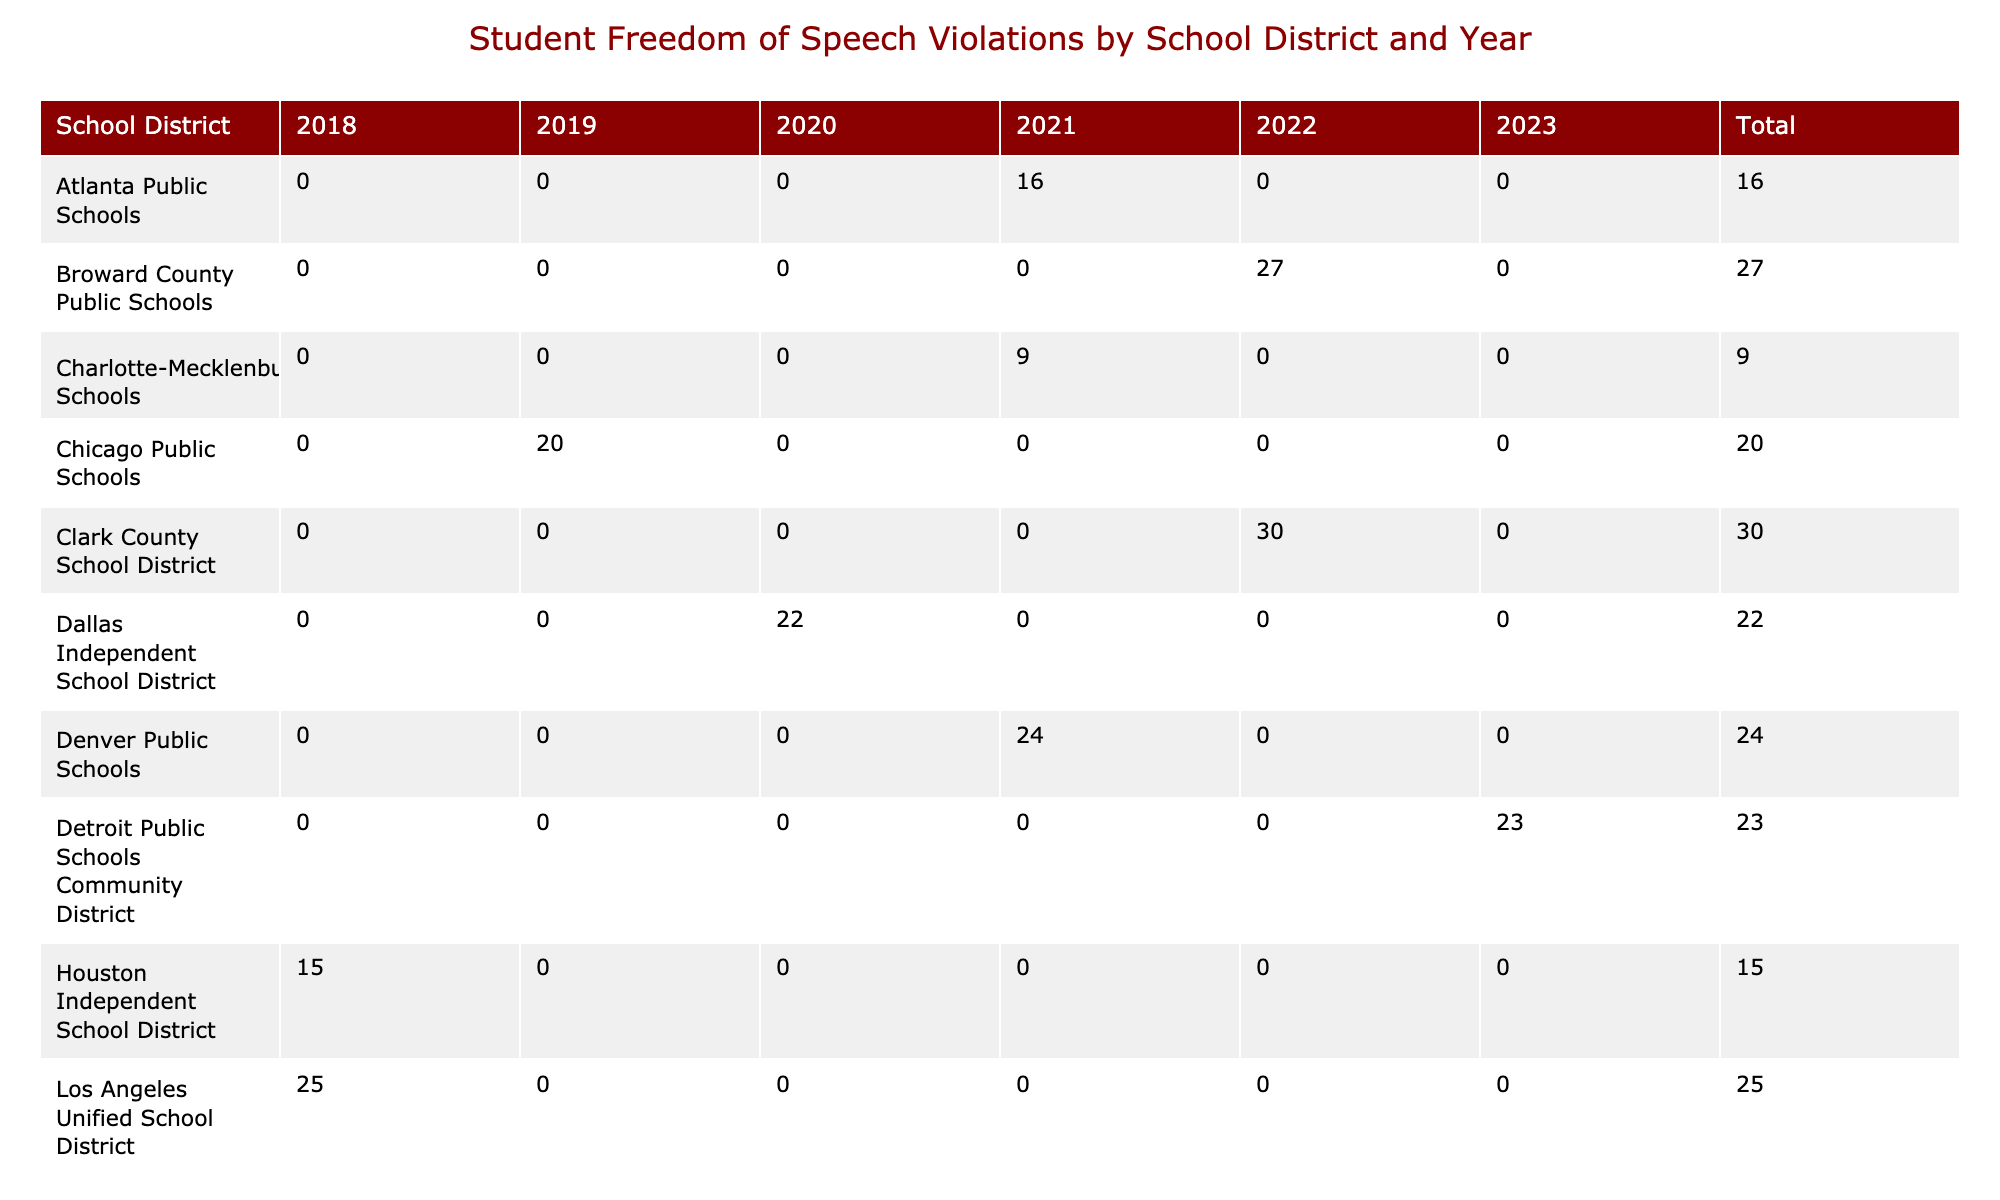What is the total number of violations in the Los Angeles Unified School District from 2018 to 2022? To find the total number of violations in the Los Angeles Unified School District from 2018 to 2022, we need to look at the row for this district and sum up the values for the years reported. According to the table, the values are 25 (2018), 0 (2019), 0 (2020), 0 (2021), and 0 (2022). Therefore, total = 25 + 0 + 0 + 0 + 0 = 25.
Answer: 25 Which school district had the highest number of violations in 2022? To answer this, we check the column for the year 2022 and compare the violations counts for each district. The highest count is 30 for the Clark County School District.
Answer: Clark County School District In which year did the New York City Department of Education report 30 violations? The table shows that the New York City Department of Education reported 30 violations in the year 2018. This can be found by locating the relevant row and checking the column for the year.
Answer: 2018 What is the average number of violations across all school districts in 2021? We first identify the total number of violations in 2021 by summing the values for each school district: 16 (Atlanta) + 24 (Denver) + 9 (Charlotte) = 49. Since there are 3 districts reporting violations in 2021, we calculate the average: 49/3 = 16.33.
Answer: 16.33 Did the total violations in 2020 exceed those in 2019? To determine this, we find the total violations for each year. For 2019, the total is 20 (Chicago) + 10 (Miami-Dade) + 18 (Seattle) = 48. For 2020, the total is 22 (Dallas) + 12 (San Francisco) + 14 (Philadelphia) = 48. Since both totals are equal, the answer is false.
Answer: No Which school district had the greatest increase in violations from 2019 to 2021? To find the greatest increase, we look at the difference in violations for each school district between 2019 and 2021. For Chicago, it went from 20 to 16 (decrease, -4), for Miami-Dade it went from 10 to 0 (decrease, -10), for Seattle it went from 18 to 0 (decrease, -18). On the other hand, Charlotte-Mecklenburg reported 0 violations in 2019 and 9 on 2021, an increase of 9. Thus, Charlotte-Mecklenburg had the greatest increase.
Answer: Charlotte-Mecklenburg Schools How many total violations were reported by all districts in 2023? To get the total violations reported in 2023, we must sum the violations for that year: 15 (Prince George's) + 23 (Detroit) + 19 (Minneapolis) = 57.
Answer: 57 Was there a school district with a total of 0 violations reported in any of the years listed? Looking through the data, we see that every school district reported some violations within the years given. Thus, no district appears to have a total of 0 violations.
Answer: No What is the total number of violations across the three years (2021-2023) reported for the Dallas Independent School District? Referring to the data for the Dallas Independent School District, it reported 22 violations in 2020, and 0 in 2021 and 2022. Therefore, the total from 2021 to 2023 is 0 + 0 + 0 = 0.
Answer: 0 